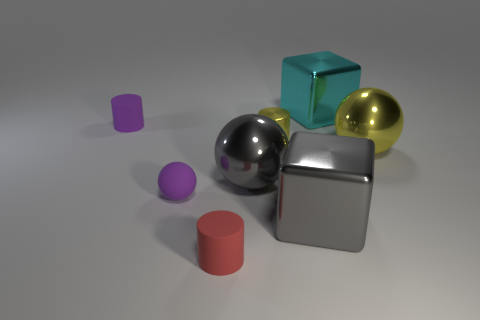How many small purple rubber objects are right of the matte cylinder behind the gray metal ball?
Your response must be concise. 1. The tiny thing right of the small matte cylinder to the right of the purple rubber cylinder behind the rubber sphere is what shape?
Keep it short and to the point. Cylinder. What size is the red rubber object?
Offer a terse response. Small. Are there any small cylinders that have the same material as the tiny ball?
Make the answer very short. Yes. There is a gray metallic thing that is the same shape as the large cyan object; what is its size?
Your answer should be very brief. Large. Are there the same number of yellow objects that are to the left of the cyan shiny cube and large blue matte cylinders?
Your response must be concise. No. There is a yellow object that is behind the yellow shiny sphere; is it the same shape as the cyan metallic object?
Provide a short and direct response. No. What is the shape of the large yellow object?
Provide a short and direct response. Sphere. What is the small purple thing that is in front of the small rubber cylinder behind the tiny object that is in front of the tiny sphere made of?
Keep it short and to the point. Rubber. There is a large ball that is the same color as the small metallic object; what material is it?
Make the answer very short. Metal. 